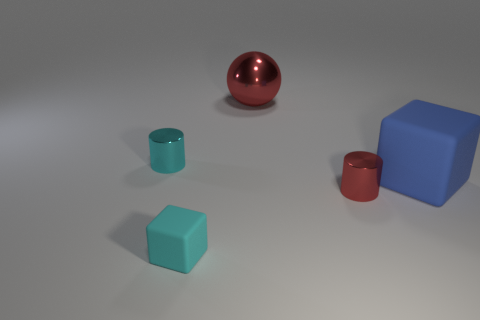Subtract all big red metal objects. Subtract all red spheres. How many objects are left? 3 Add 2 tiny cyan shiny things. How many tiny cyan shiny things are left? 3 Add 3 cyan cubes. How many cyan cubes exist? 4 Add 1 small cyan things. How many objects exist? 6 Subtract 0 green cylinders. How many objects are left? 5 Subtract all blocks. How many objects are left? 3 Subtract 1 cylinders. How many cylinders are left? 1 Subtract all yellow balls. Subtract all gray cubes. How many balls are left? 1 Subtract all cyan cubes. How many blue cylinders are left? 0 